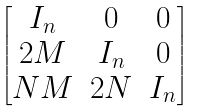Convert formula to latex. <formula><loc_0><loc_0><loc_500><loc_500>\begin{bmatrix} I _ { n } & 0 & 0 \\ 2 M & I _ { n } & 0 \\ N M & 2 N & I _ { n } \end{bmatrix}</formula> 